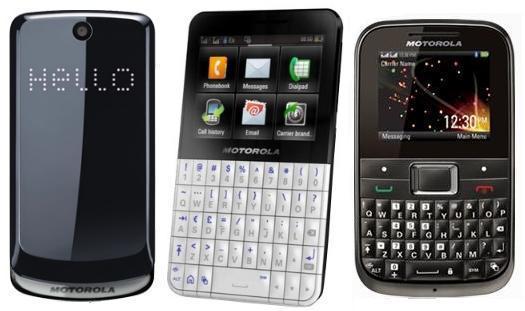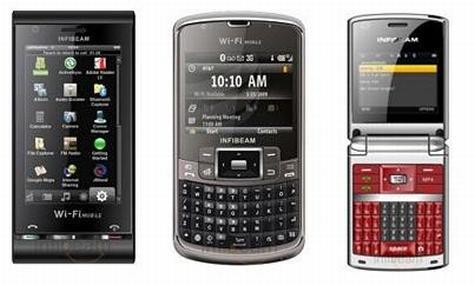The first image is the image on the left, the second image is the image on the right. For the images shown, is this caption "The right image shows exactly three phones, which are displayed upright and spaced apart instead of overlapping." true? Answer yes or no. Yes. The first image is the image on the left, the second image is the image on the right. Examine the images to the left and right. Is the description "The left and right image contains the same number of phones that a vertical." accurate? Answer yes or no. Yes. 